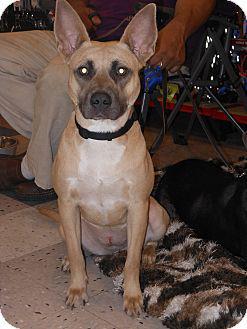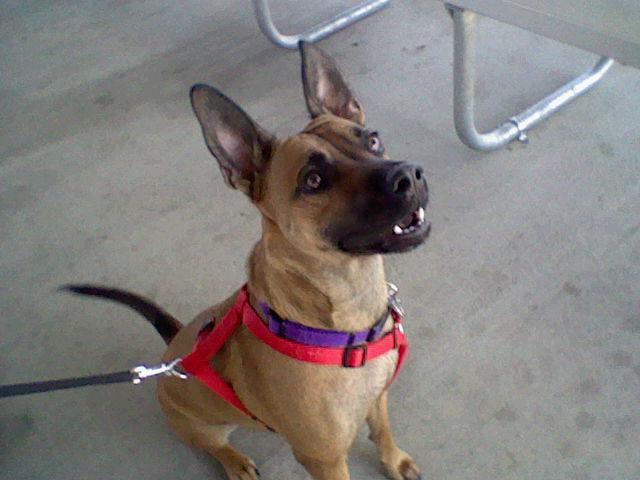The first image is the image on the left, the second image is the image on the right. Considering the images on both sides, is "Left image contains one tan adult dog wearing a collar." valid? Answer yes or no. Yes. 